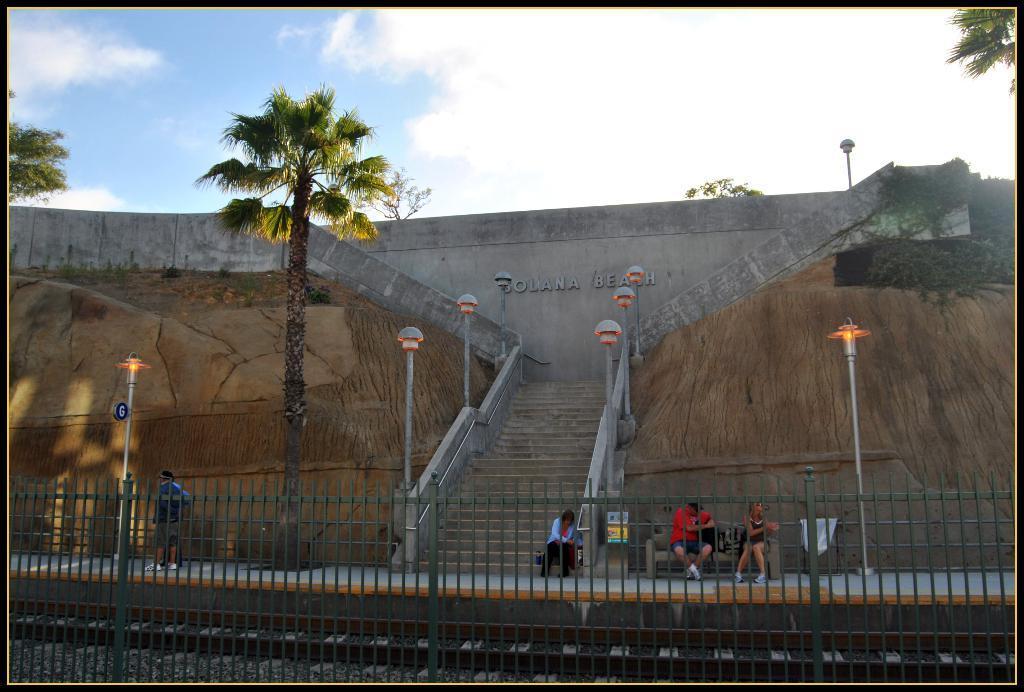Describe this image in one or two sentences. In this image we can see there is a railing, behind the railing there is a railway track and a few people are standing and sitting on the bench, which is on the pavement, one of them is sitting on the stairs, there are a few poles with lamps connected, trees, above the stairs there is a wall with some text on it. In the background there is the sky. 